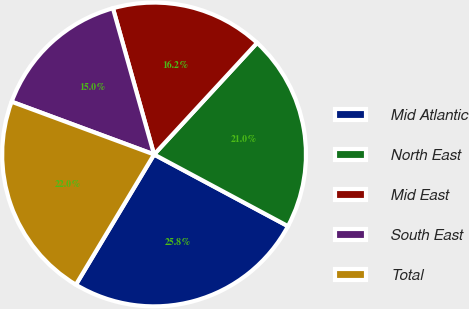Convert chart to OTSL. <chart><loc_0><loc_0><loc_500><loc_500><pie_chart><fcel>Mid Atlantic<fcel>North East<fcel>Mid East<fcel>South East<fcel>Total<nl><fcel>25.78%<fcel>20.96%<fcel>16.23%<fcel>14.99%<fcel>22.04%<nl></chart> 